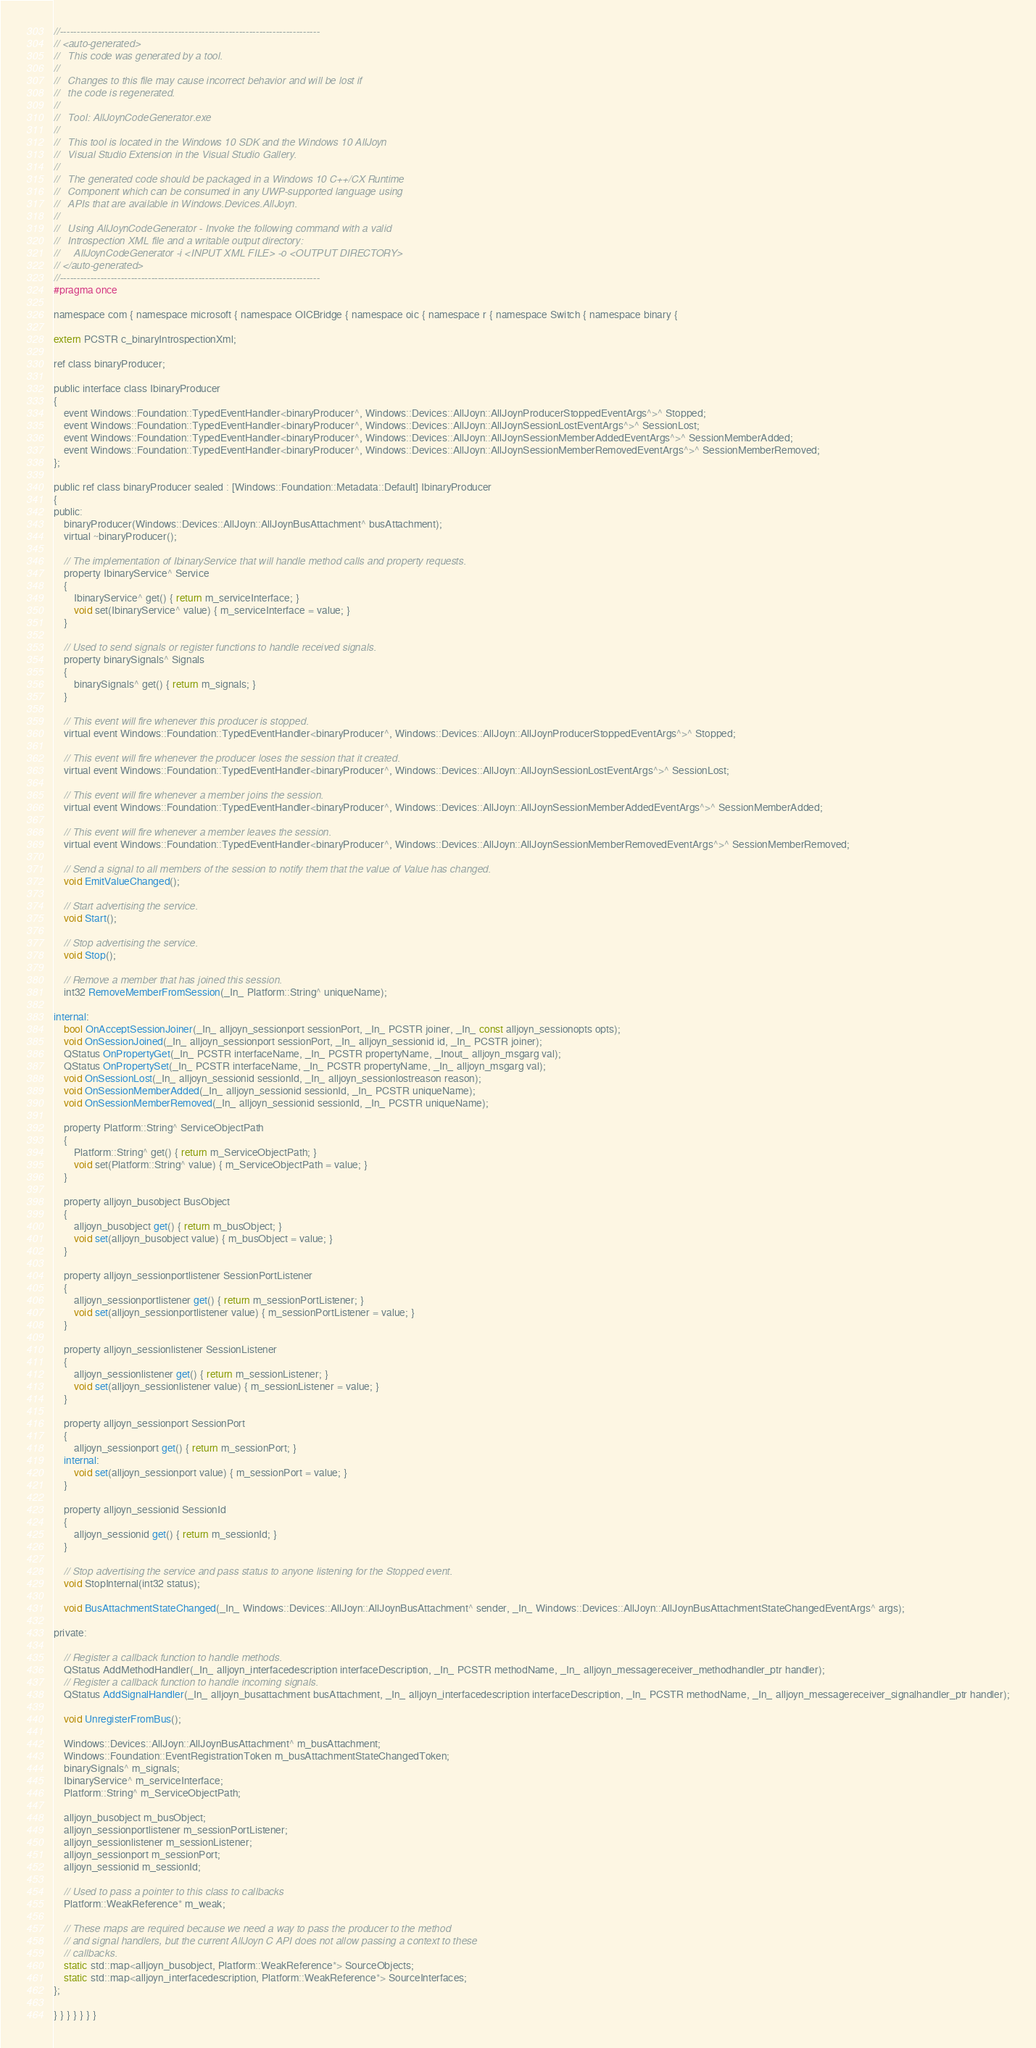<code> <loc_0><loc_0><loc_500><loc_500><_C_>//-----------------------------------------------------------------------------
// <auto-generated> 
//   This code was generated by a tool. 
// 
//   Changes to this file may cause incorrect behavior and will be lost if  
//   the code is regenerated.
//
//   Tool: AllJoynCodeGenerator.exe
//
//   This tool is located in the Windows 10 SDK and the Windows 10 AllJoyn 
//   Visual Studio Extension in the Visual Studio Gallery.  
//
//   The generated code should be packaged in a Windows 10 C++/CX Runtime  
//   Component which can be consumed in any UWP-supported language using 
//   APIs that are available in Windows.Devices.AllJoyn.
//
//   Using AllJoynCodeGenerator - Invoke the following command with a valid 
//   Introspection XML file and a writable output directory:
//     AllJoynCodeGenerator -i <INPUT XML FILE> -o <OUTPUT DIRECTORY>
// </auto-generated>
//-----------------------------------------------------------------------------
#pragma once

namespace com { namespace microsoft { namespace OICBridge { namespace oic { namespace r { namespace Switch { namespace binary {

extern PCSTR c_binaryIntrospectionXml;

ref class binaryProducer;

public interface class IbinaryProducer
{
    event Windows::Foundation::TypedEventHandler<binaryProducer^, Windows::Devices::AllJoyn::AllJoynProducerStoppedEventArgs^>^ Stopped;
    event Windows::Foundation::TypedEventHandler<binaryProducer^, Windows::Devices::AllJoyn::AllJoynSessionLostEventArgs^>^ SessionLost;
    event Windows::Foundation::TypedEventHandler<binaryProducer^, Windows::Devices::AllJoyn::AllJoynSessionMemberAddedEventArgs^>^ SessionMemberAdded;
    event Windows::Foundation::TypedEventHandler<binaryProducer^, Windows::Devices::AllJoyn::AllJoynSessionMemberRemovedEventArgs^>^ SessionMemberRemoved;
};

public ref class binaryProducer sealed : [Windows::Foundation::Metadata::Default] IbinaryProducer
{
public:
    binaryProducer(Windows::Devices::AllJoyn::AllJoynBusAttachment^ busAttachment);
    virtual ~binaryProducer();

    // The implementation of IbinaryService that will handle method calls and property requests.
    property IbinaryService^ Service
    {
        IbinaryService^ get() { return m_serviceInterface; }
        void set(IbinaryService^ value) { m_serviceInterface = value; }
    }

    // Used to send signals or register functions to handle received signals.
    property binarySignals^ Signals
    {
        binarySignals^ get() { return m_signals; }
    }
    
    // This event will fire whenever this producer is stopped.
    virtual event Windows::Foundation::TypedEventHandler<binaryProducer^, Windows::Devices::AllJoyn::AllJoynProducerStoppedEventArgs^>^ Stopped;
    
    // This event will fire whenever the producer loses the session that it created.
    virtual event Windows::Foundation::TypedEventHandler<binaryProducer^, Windows::Devices::AllJoyn::AllJoynSessionLostEventArgs^>^ SessionLost;
    
    // This event will fire whenever a member joins the session.
    virtual event Windows::Foundation::TypedEventHandler<binaryProducer^, Windows::Devices::AllJoyn::AllJoynSessionMemberAddedEventArgs^>^ SessionMemberAdded;

    // This event will fire whenever a member leaves the session.
    virtual event Windows::Foundation::TypedEventHandler<binaryProducer^, Windows::Devices::AllJoyn::AllJoynSessionMemberRemovedEventArgs^>^ SessionMemberRemoved;

    // Send a signal to all members of the session to notify them that the value of Value has changed.
    void EmitValueChanged();

    // Start advertising the service.
    void Start();
    
    // Stop advertising the service.
    void Stop();
    
    // Remove a member that has joined this session.
    int32 RemoveMemberFromSession(_In_ Platform::String^ uniqueName);
    
internal:
    bool OnAcceptSessionJoiner(_In_ alljoyn_sessionport sessionPort, _In_ PCSTR joiner, _In_ const alljoyn_sessionopts opts);
    void OnSessionJoined(_In_ alljoyn_sessionport sessionPort, _In_ alljoyn_sessionid id, _In_ PCSTR joiner);
    QStatus OnPropertyGet(_In_ PCSTR interfaceName, _In_ PCSTR propertyName, _Inout_ alljoyn_msgarg val);
    QStatus OnPropertySet(_In_ PCSTR interfaceName, _In_ PCSTR propertyName, _In_ alljoyn_msgarg val);
    void OnSessionLost(_In_ alljoyn_sessionid sessionId, _In_ alljoyn_sessionlostreason reason);
    void OnSessionMemberAdded(_In_ alljoyn_sessionid sessionId, _In_ PCSTR uniqueName);
    void OnSessionMemberRemoved(_In_ alljoyn_sessionid sessionId, _In_ PCSTR uniqueName);

    property Platform::String^ ServiceObjectPath
    {
        Platform::String^ get() { return m_ServiceObjectPath; }
        void set(Platform::String^ value) { m_ServiceObjectPath = value; }
    }

    property alljoyn_busobject BusObject
    {
        alljoyn_busobject get() { return m_busObject; }
        void set(alljoyn_busobject value) { m_busObject = value; }
    }

    property alljoyn_sessionportlistener SessionPortListener
    {
        alljoyn_sessionportlistener get() { return m_sessionPortListener; }
        void set(alljoyn_sessionportlistener value) { m_sessionPortListener = value; }
    }
    
    property alljoyn_sessionlistener SessionListener
    {
        alljoyn_sessionlistener get() { return m_sessionListener; }
        void set(alljoyn_sessionlistener value) { m_sessionListener = value; }
    }

    property alljoyn_sessionport SessionPort
    {
        alljoyn_sessionport get() { return m_sessionPort; }
    internal: 
        void set(alljoyn_sessionport value) { m_sessionPort = value; }
    }

    property alljoyn_sessionid SessionId
    {
        alljoyn_sessionid get() { return m_sessionId; }
    }
    
    // Stop advertising the service and pass status to anyone listening for the Stopped event.
    void StopInternal(int32 status);

    void BusAttachmentStateChanged(_In_ Windows::Devices::AllJoyn::AllJoynBusAttachment^ sender, _In_ Windows::Devices::AllJoyn::AllJoynBusAttachmentStateChangedEventArgs^ args);

private:
      
    // Register a callback function to handle methods.
    QStatus AddMethodHandler(_In_ alljoyn_interfacedescription interfaceDescription, _In_ PCSTR methodName, _In_ alljoyn_messagereceiver_methodhandler_ptr handler);
    // Register a callback function to handle incoming signals.
    QStatus AddSignalHandler(_In_ alljoyn_busattachment busAttachment, _In_ alljoyn_interfacedescription interfaceDescription, _In_ PCSTR methodName, _In_ alljoyn_messagereceiver_signalhandler_ptr handler);
    
    void UnregisterFromBus();
    
    Windows::Devices::AllJoyn::AllJoynBusAttachment^ m_busAttachment;
    Windows::Foundation::EventRegistrationToken m_busAttachmentStateChangedToken;
    binarySignals^ m_signals;
    IbinaryService^ m_serviceInterface;
    Platform::String^ m_ServiceObjectPath;

    alljoyn_busobject m_busObject;
    alljoyn_sessionportlistener m_sessionPortListener;
    alljoyn_sessionlistener m_sessionListener;
    alljoyn_sessionport m_sessionPort;
    alljoyn_sessionid m_sessionId;

    // Used to pass a pointer to this class to callbacks
    Platform::WeakReference* m_weak;

    // These maps are required because we need a way to pass the producer to the method
    // and signal handlers, but the current AllJoyn C API does not allow passing a context to these
    // callbacks.
    static std::map<alljoyn_busobject, Platform::WeakReference*> SourceObjects;
    static std::map<alljoyn_interfacedescription, Platform::WeakReference*> SourceInterfaces;
};

} } } } } } }
</code> 